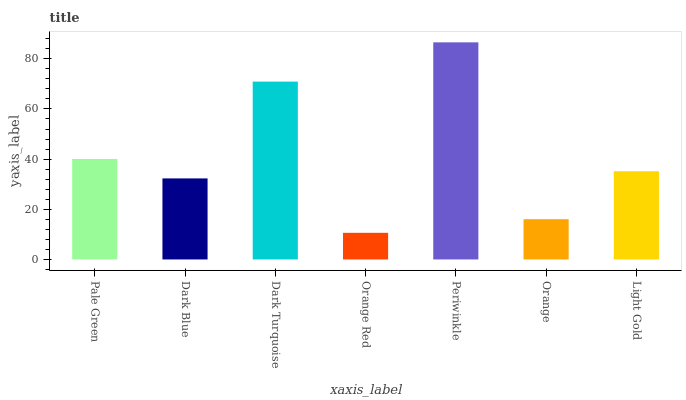Is Orange Red the minimum?
Answer yes or no. Yes. Is Periwinkle the maximum?
Answer yes or no. Yes. Is Dark Blue the minimum?
Answer yes or no. No. Is Dark Blue the maximum?
Answer yes or no. No. Is Pale Green greater than Dark Blue?
Answer yes or no. Yes. Is Dark Blue less than Pale Green?
Answer yes or no. Yes. Is Dark Blue greater than Pale Green?
Answer yes or no. No. Is Pale Green less than Dark Blue?
Answer yes or no. No. Is Light Gold the high median?
Answer yes or no. Yes. Is Light Gold the low median?
Answer yes or no. Yes. Is Dark Turquoise the high median?
Answer yes or no. No. Is Orange Red the low median?
Answer yes or no. No. 